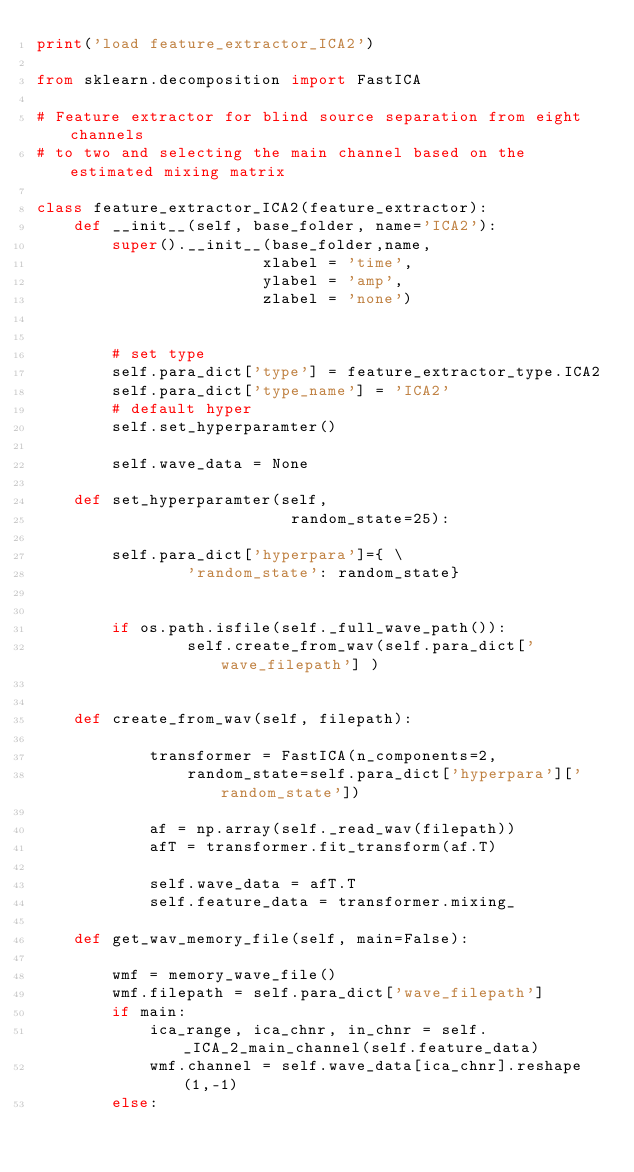<code> <loc_0><loc_0><loc_500><loc_500><_Python_>print('load feature_extractor_ICA2')

from sklearn.decomposition import FastICA

# Feature extractor for blind source separation from eight channels 
# to two and selecting the main channel based on the estimated mixing matrix

class feature_extractor_ICA2(feature_extractor):
    def __init__(self, base_folder, name='ICA2'):
        super().__init__(base_folder,name,
                        xlabel = 'time',
                        ylabel = 'amp',
                        zlabel = 'none')
        
        
        # set type
        self.para_dict['type'] = feature_extractor_type.ICA2
        self.para_dict['type_name'] = 'ICA2'
        # default hyper
        self.set_hyperparamter()
        
        self.wave_data = None
     
    def set_hyperparamter(self,
                           random_state=25):

        self.para_dict['hyperpara']={ \
                'random_state': random_state}
        

        if os.path.isfile(self._full_wave_path()):
                self.create_from_wav(self.para_dict['wave_filepath'] )
                
        
    def create_from_wav(self, filepath):
        
            transformer = FastICA(n_components=2, 
                random_state=self.para_dict['hyperpara']['random_state'])
                
            af = np.array(self._read_wav(filepath))
            afT = transformer.fit_transform(af.T)
            
            self.wave_data = afT.T
            self.feature_data = transformer.mixing_
            
    def get_wav_memory_file(self, main=False):
            
        wmf = memory_wave_file()
        wmf.filepath = self.para_dict['wave_filepath']
        if main:
            ica_range, ica_chnr, in_chnr = self._ICA_2_main_channel(self.feature_data)
            wmf.channel = self.wave_data[ica_chnr].reshape(1,-1)
        else:</code> 